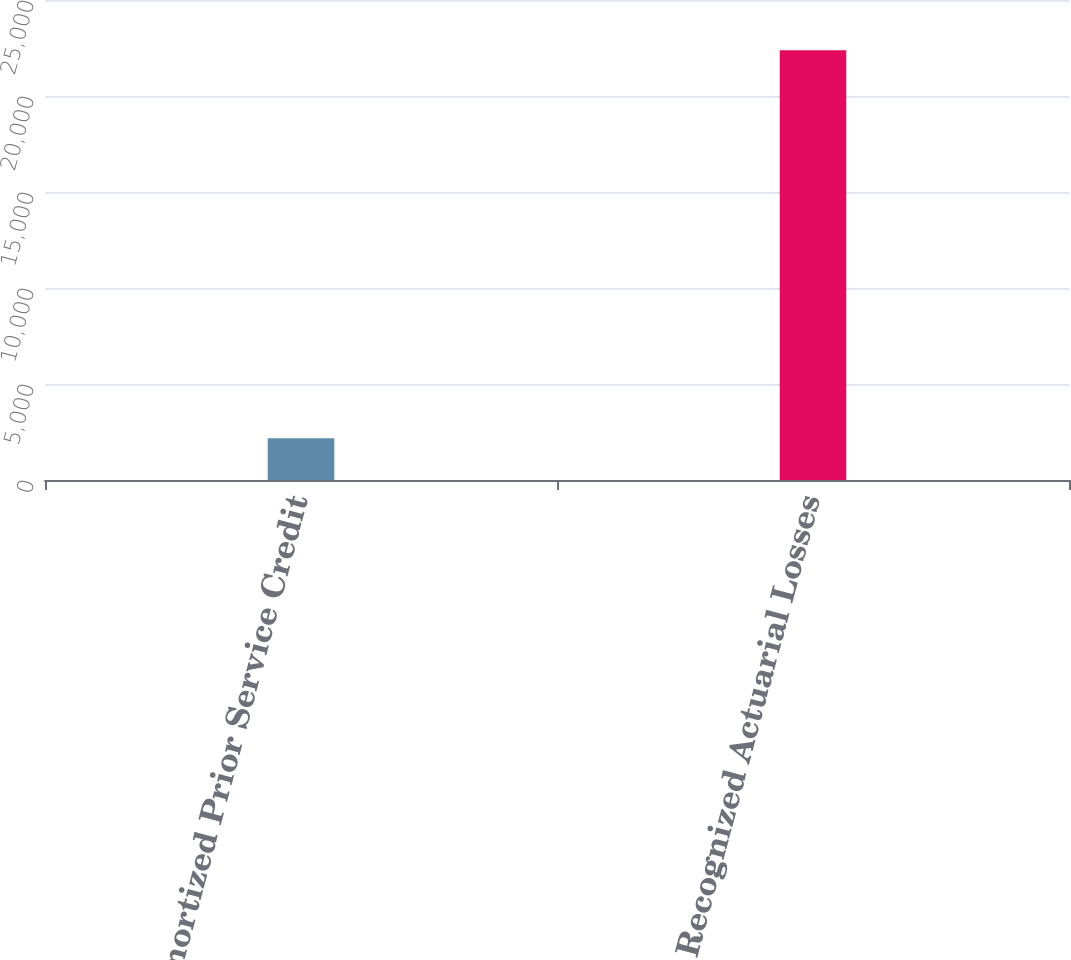Convert chart to OTSL. <chart><loc_0><loc_0><loc_500><loc_500><bar_chart><fcel>Amortized Prior Service Credit<fcel>Recognized Actuarial Losses<nl><fcel>2168<fcel>22383<nl></chart> 